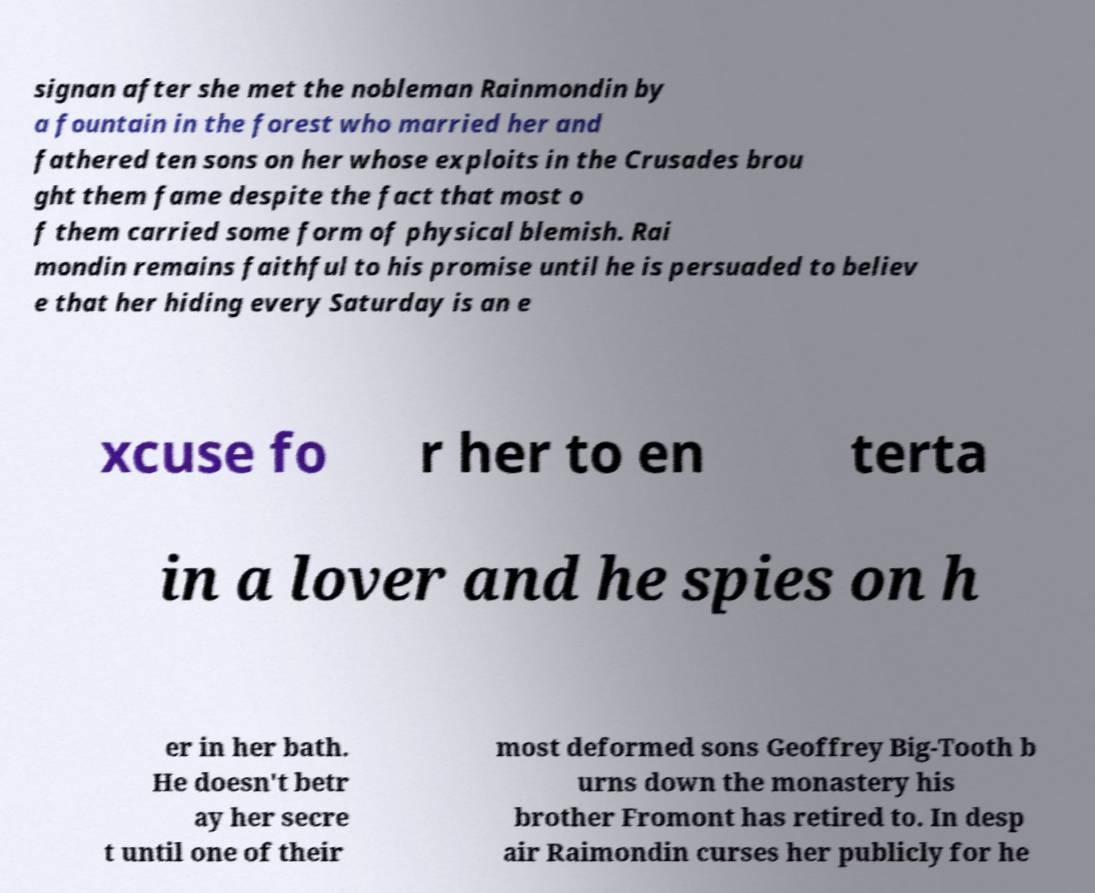Could you assist in decoding the text presented in this image and type it out clearly? signan after she met the nobleman Rainmondin by a fountain in the forest who married her and fathered ten sons on her whose exploits in the Crusades brou ght them fame despite the fact that most o f them carried some form of physical blemish. Rai mondin remains faithful to his promise until he is persuaded to believ e that her hiding every Saturday is an e xcuse fo r her to en terta in a lover and he spies on h er in her bath. He doesn't betr ay her secre t until one of their most deformed sons Geoffrey Big-Tooth b urns down the monastery his brother Fromont has retired to. In desp air Raimondin curses her publicly for he 